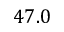Convert formula to latex. <formula><loc_0><loc_0><loc_500><loc_500>4 7 . 0</formula> 